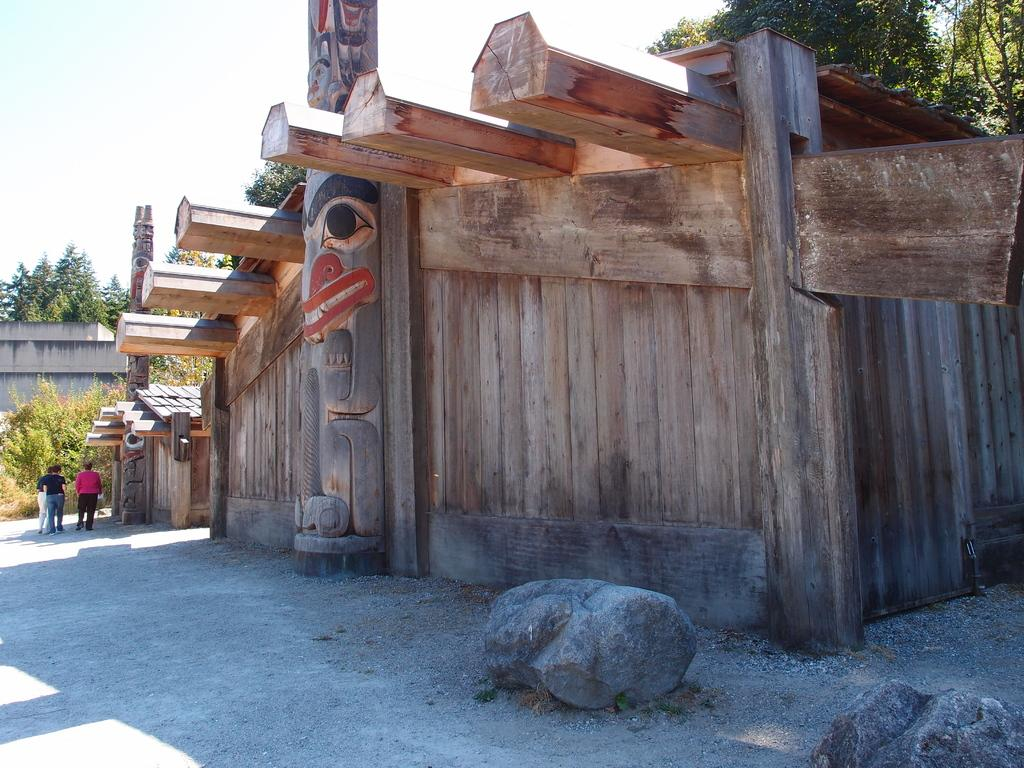What type of wall is visible in the image? There is a wooden wall in the image. Can you describe the people in the image? There is a group of people standing in the image. What natural elements can be seen in the image? There are trees and rocks in the image. What is visible in the background of the image? The sky is visible in the background of the image. What type of stocking is being worn by the trees in the image? There are no stockings present in the image, as the trees are natural elements. Can you tell me what the people are writing on the wooden wall in the image? There is no writing activity taking place in the image; the people are simply standing. 